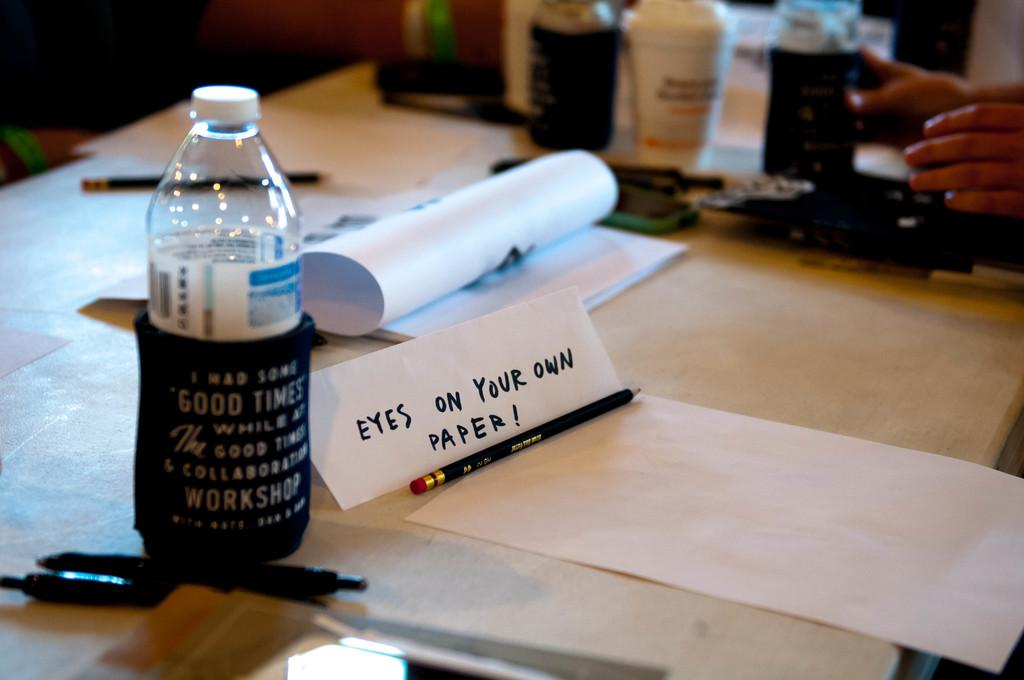Provide a one-sentence caption for the provided image. A work desk with pens, a water bottle and paper on it. One piece of paper is folded into a sign that says Eyes on Your Own Paper. 